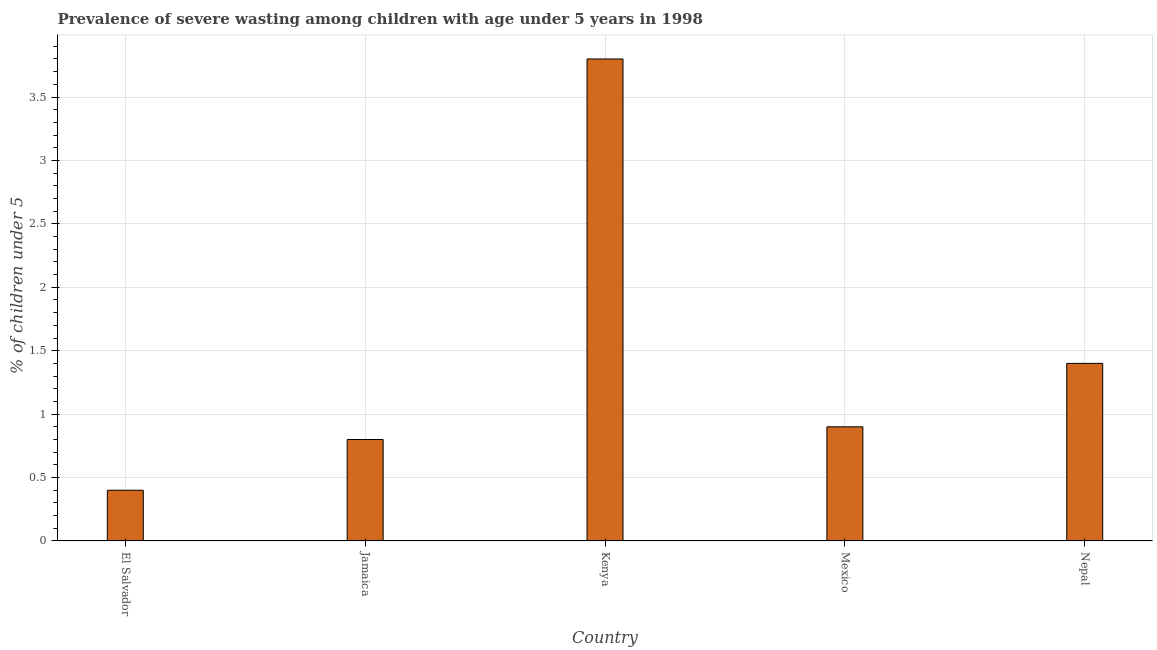What is the title of the graph?
Ensure brevity in your answer.  Prevalence of severe wasting among children with age under 5 years in 1998. What is the label or title of the Y-axis?
Offer a terse response.  % of children under 5. What is the prevalence of severe wasting in El Salvador?
Your response must be concise. 0.4. Across all countries, what is the maximum prevalence of severe wasting?
Offer a terse response. 3.8. Across all countries, what is the minimum prevalence of severe wasting?
Keep it short and to the point. 0.4. In which country was the prevalence of severe wasting maximum?
Your answer should be compact. Kenya. In which country was the prevalence of severe wasting minimum?
Keep it short and to the point. El Salvador. What is the sum of the prevalence of severe wasting?
Your answer should be compact. 7.3. What is the difference between the prevalence of severe wasting in Jamaica and Kenya?
Your answer should be compact. -3. What is the average prevalence of severe wasting per country?
Ensure brevity in your answer.  1.46. What is the median prevalence of severe wasting?
Keep it short and to the point. 0.9. What is the ratio of the prevalence of severe wasting in Mexico to that in Nepal?
Offer a very short reply. 0.64. Is the prevalence of severe wasting in Jamaica less than that in Nepal?
Keep it short and to the point. Yes. What is the difference between the highest and the lowest prevalence of severe wasting?
Offer a very short reply. 3.4. Are all the bars in the graph horizontal?
Your answer should be very brief. No. Are the values on the major ticks of Y-axis written in scientific E-notation?
Provide a succinct answer. No. What is the  % of children under 5 in El Salvador?
Ensure brevity in your answer.  0.4. What is the  % of children under 5 of Jamaica?
Your answer should be compact. 0.8. What is the  % of children under 5 in Kenya?
Provide a succinct answer. 3.8. What is the  % of children under 5 of Mexico?
Make the answer very short. 0.9. What is the  % of children under 5 in Nepal?
Make the answer very short. 1.4. What is the difference between the  % of children under 5 in El Salvador and Jamaica?
Provide a succinct answer. -0.4. What is the difference between the  % of children under 5 in El Salvador and Mexico?
Ensure brevity in your answer.  -0.5. What is the difference between the  % of children under 5 in El Salvador and Nepal?
Ensure brevity in your answer.  -1. What is the difference between the  % of children under 5 in Jamaica and Mexico?
Provide a short and direct response. -0.1. What is the difference between the  % of children under 5 in Jamaica and Nepal?
Keep it short and to the point. -0.6. What is the difference between the  % of children under 5 in Kenya and Nepal?
Provide a succinct answer. 2.4. What is the difference between the  % of children under 5 in Mexico and Nepal?
Give a very brief answer. -0.5. What is the ratio of the  % of children under 5 in El Salvador to that in Jamaica?
Offer a very short reply. 0.5. What is the ratio of the  % of children under 5 in El Salvador to that in Kenya?
Your response must be concise. 0.1. What is the ratio of the  % of children under 5 in El Salvador to that in Mexico?
Offer a very short reply. 0.44. What is the ratio of the  % of children under 5 in El Salvador to that in Nepal?
Ensure brevity in your answer.  0.29. What is the ratio of the  % of children under 5 in Jamaica to that in Kenya?
Give a very brief answer. 0.21. What is the ratio of the  % of children under 5 in Jamaica to that in Mexico?
Offer a very short reply. 0.89. What is the ratio of the  % of children under 5 in Jamaica to that in Nepal?
Provide a short and direct response. 0.57. What is the ratio of the  % of children under 5 in Kenya to that in Mexico?
Offer a terse response. 4.22. What is the ratio of the  % of children under 5 in Kenya to that in Nepal?
Your answer should be compact. 2.71. What is the ratio of the  % of children under 5 in Mexico to that in Nepal?
Your answer should be compact. 0.64. 